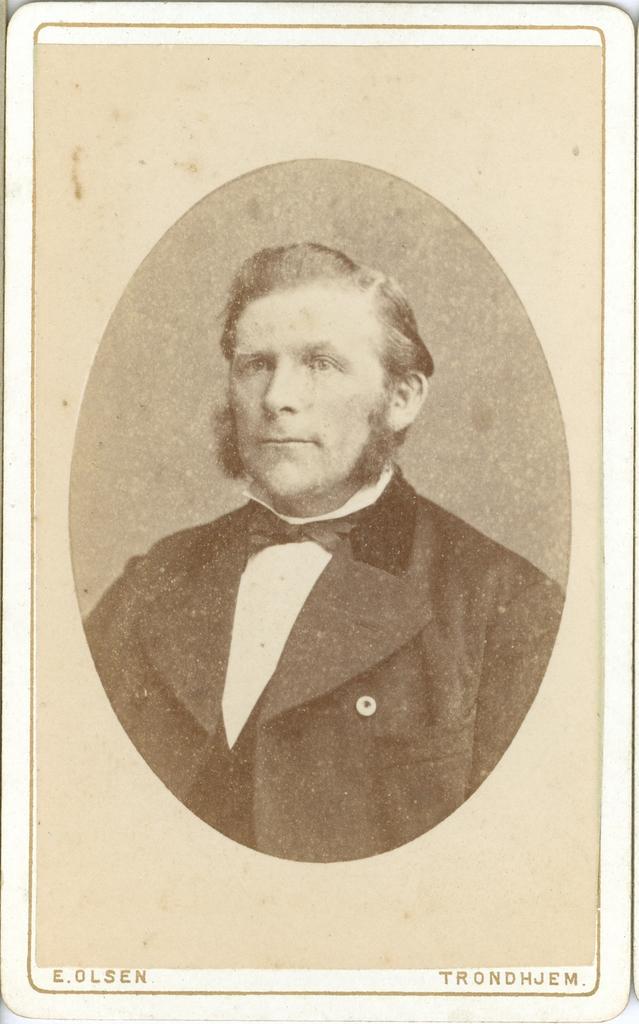Could you give a brief overview of what you see in this image? In the image we can see a frame. 